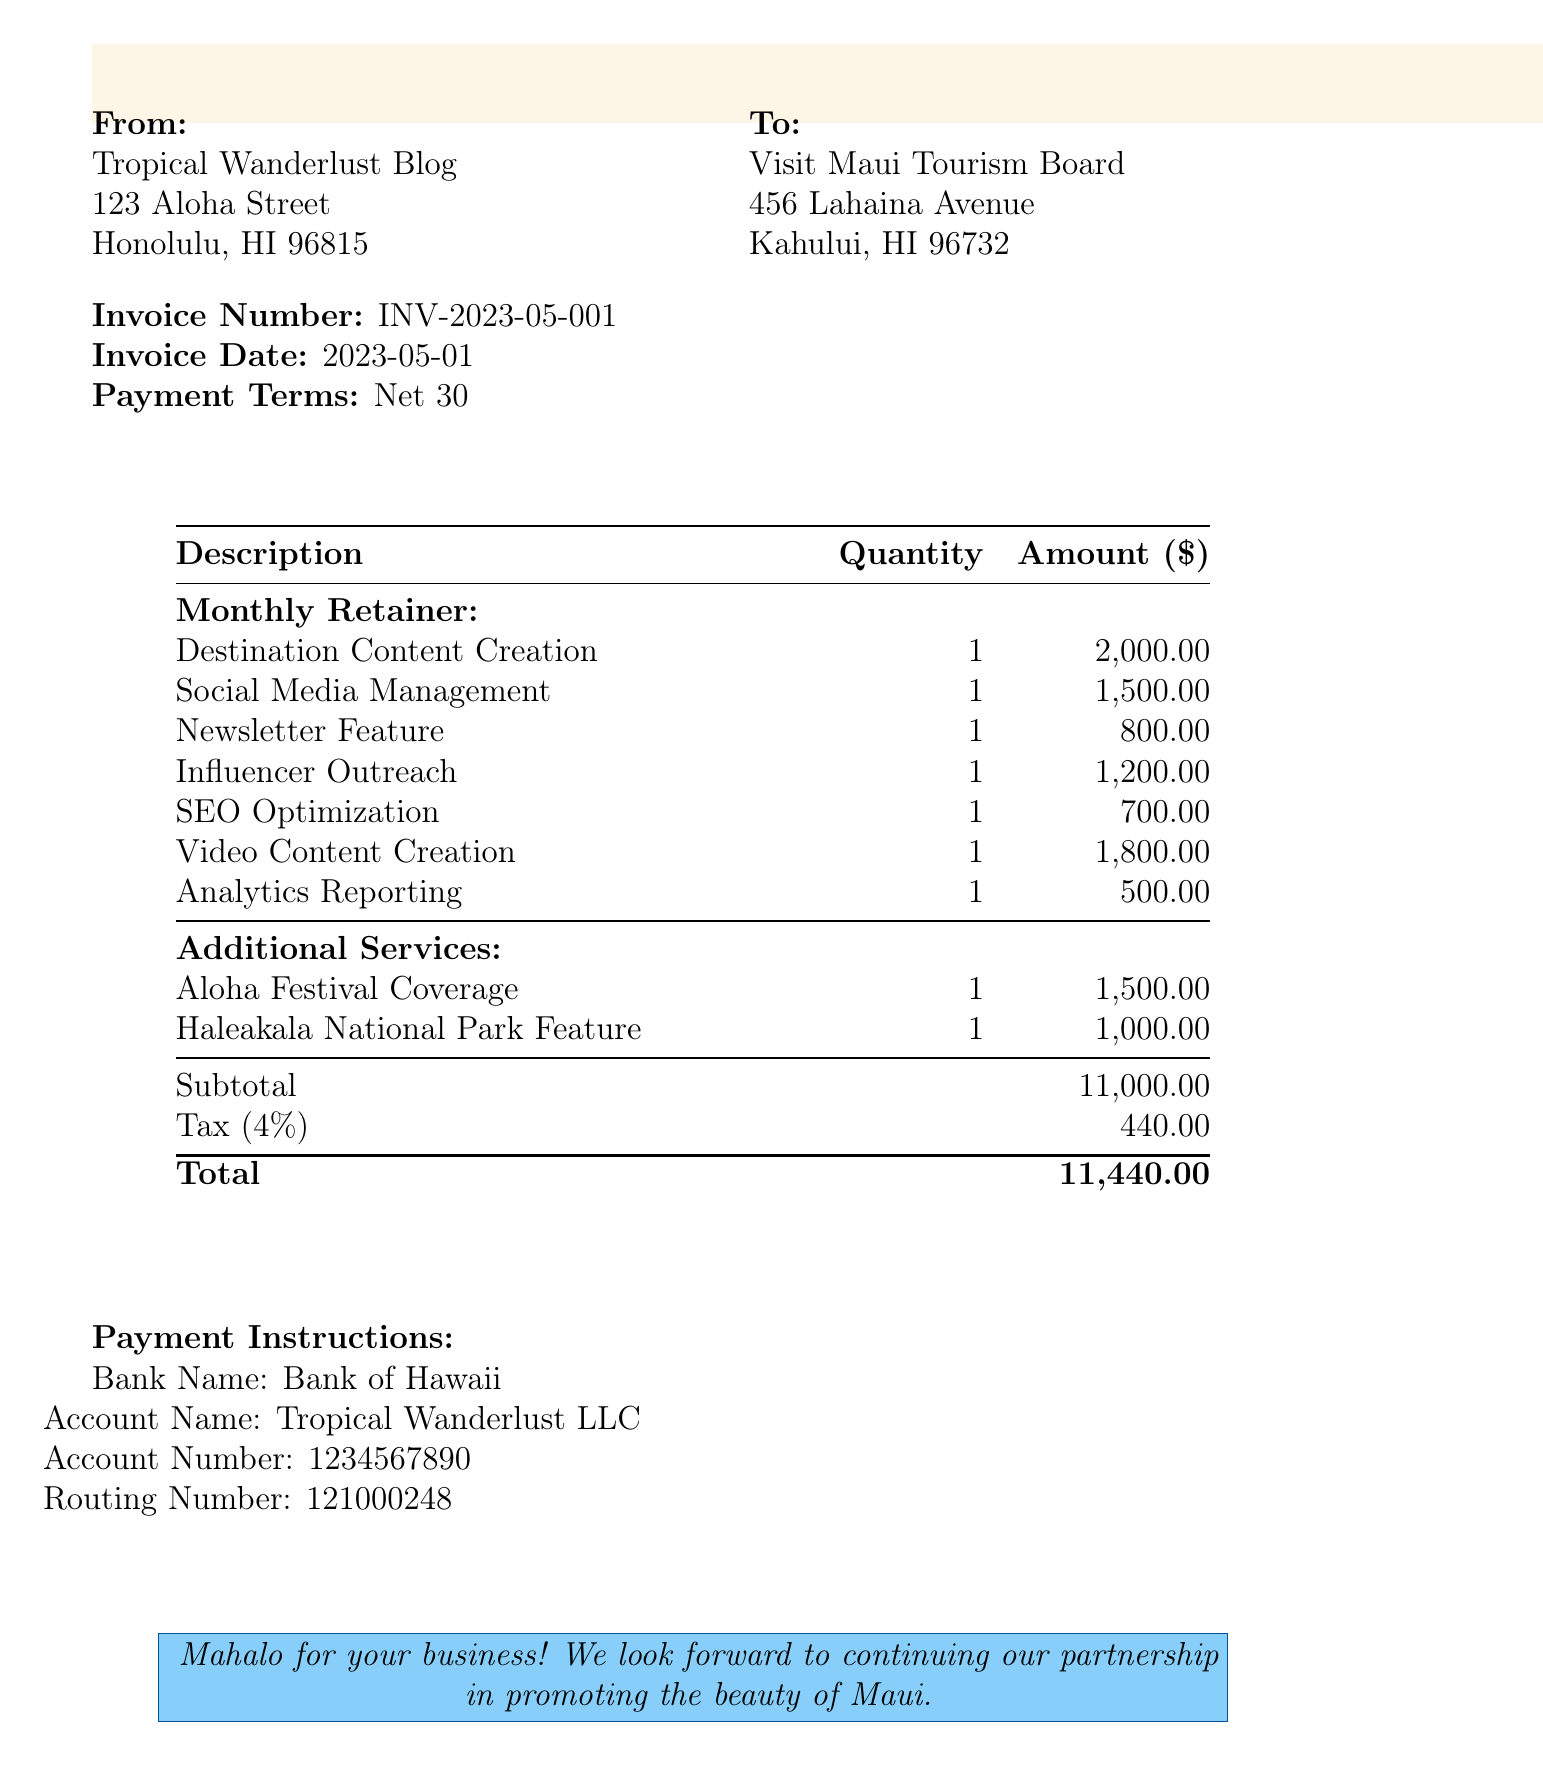What is the invoice number? The invoice number is specified in the document for easy reference relating to this transaction.
Answer: INV-2023-05-001 What is the total amount due? The total amount due is calculated by adding the subtotal and tax amounts listed in the invoice.
Answer: 11,440.00 When is the invoice date? The invoice date indicates when the invoice was issued, which is essential for payment terms.
Answer: 2023-05-01 How much is allocated for social media management? The amount for social media management is detailed as part of the monthly retainer breakdown.
Answer: 1,500.00 How many blog posts are included in the destination content creation? This is related to the quantity of content specified for the destination promotion.
Answer: 4 What percentage is the tax rate applied? The tax rate is mentioned in the invoice, which contributes to the total amount due.
Answer: 4% What is included in the additional services? This relates to extra offerings that can enhance promotional activities as specified in the document.
Answer: Aloha Festival Coverage, Haleakala National Park Feature What payment terms are stated? The payment terms outline the timeframe allowed for payment submission after receiving the invoice.
Answer: Net 30 Which bank should the payment be directed to? This detail is essential for the client to process the payment correctly.
Answer: Bank of Hawaii 